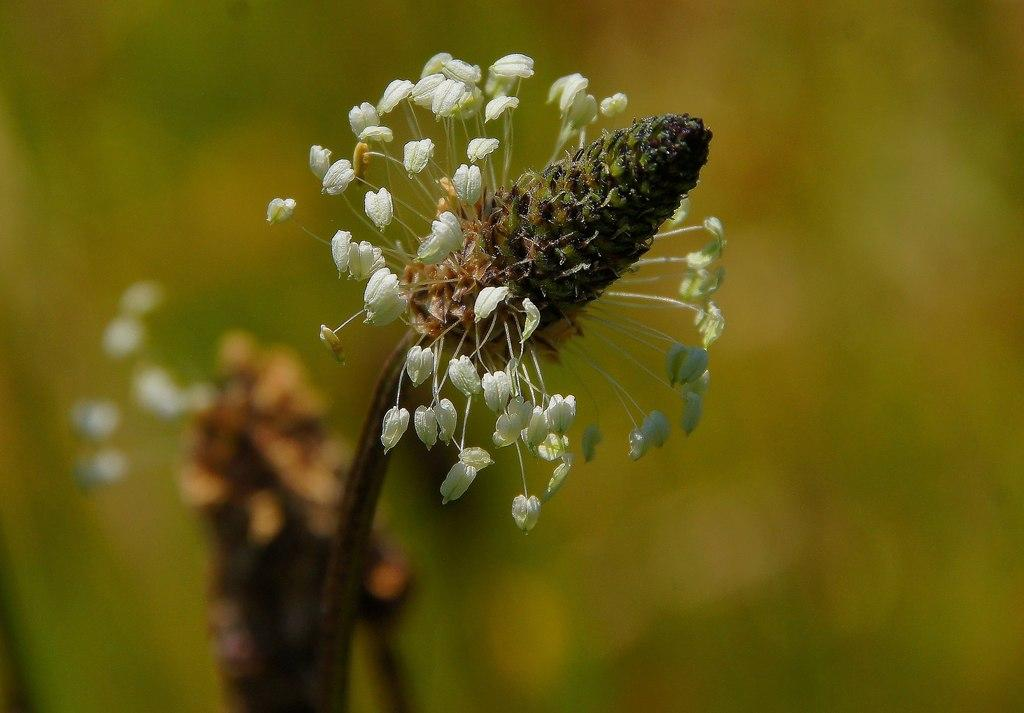What is the main subject of the image? The main subject of the image is a flower. Can you describe the flower's origin? The flower belongs to a plant. What is the appearance of the background in the image? The background of the image is blurred. What type of book is being read by the snow in the image? There is no book or snow present in the image; it features a flower and a blurred background. 